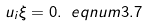<formula> <loc_0><loc_0><loc_500><loc_500>u _ { i } \xi = 0 . \ e q n u m { 3 . 7 }</formula> 